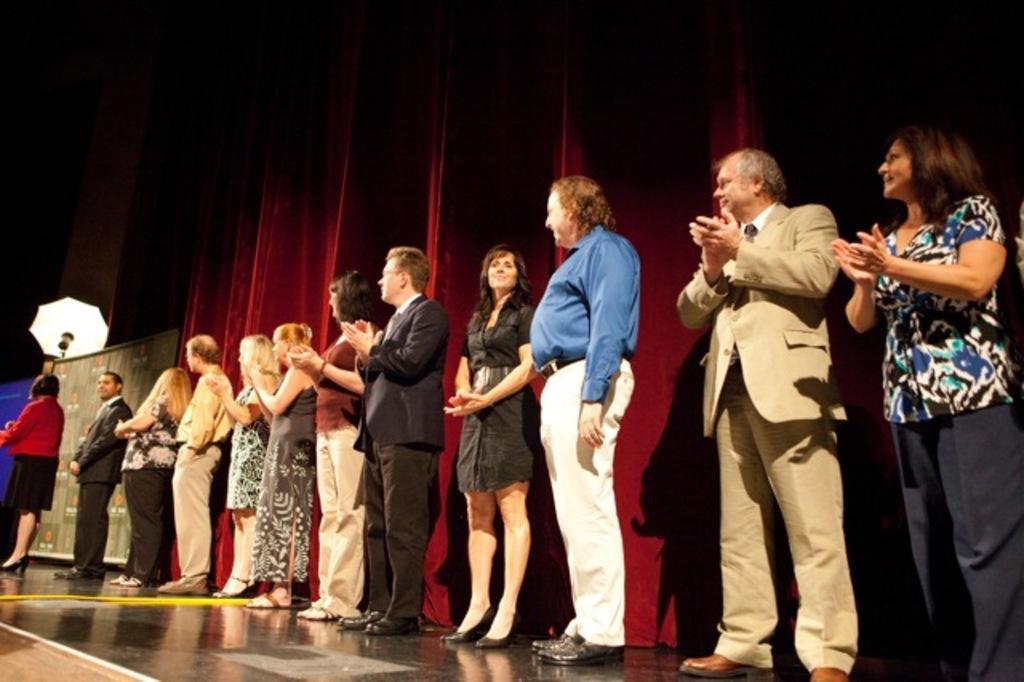Describe this image in one or two sentences. In this image, we can see a group of people are standing. Few are clapping their hands. Background we can see a curtain. On the left side, we can see banners and umbrella. 